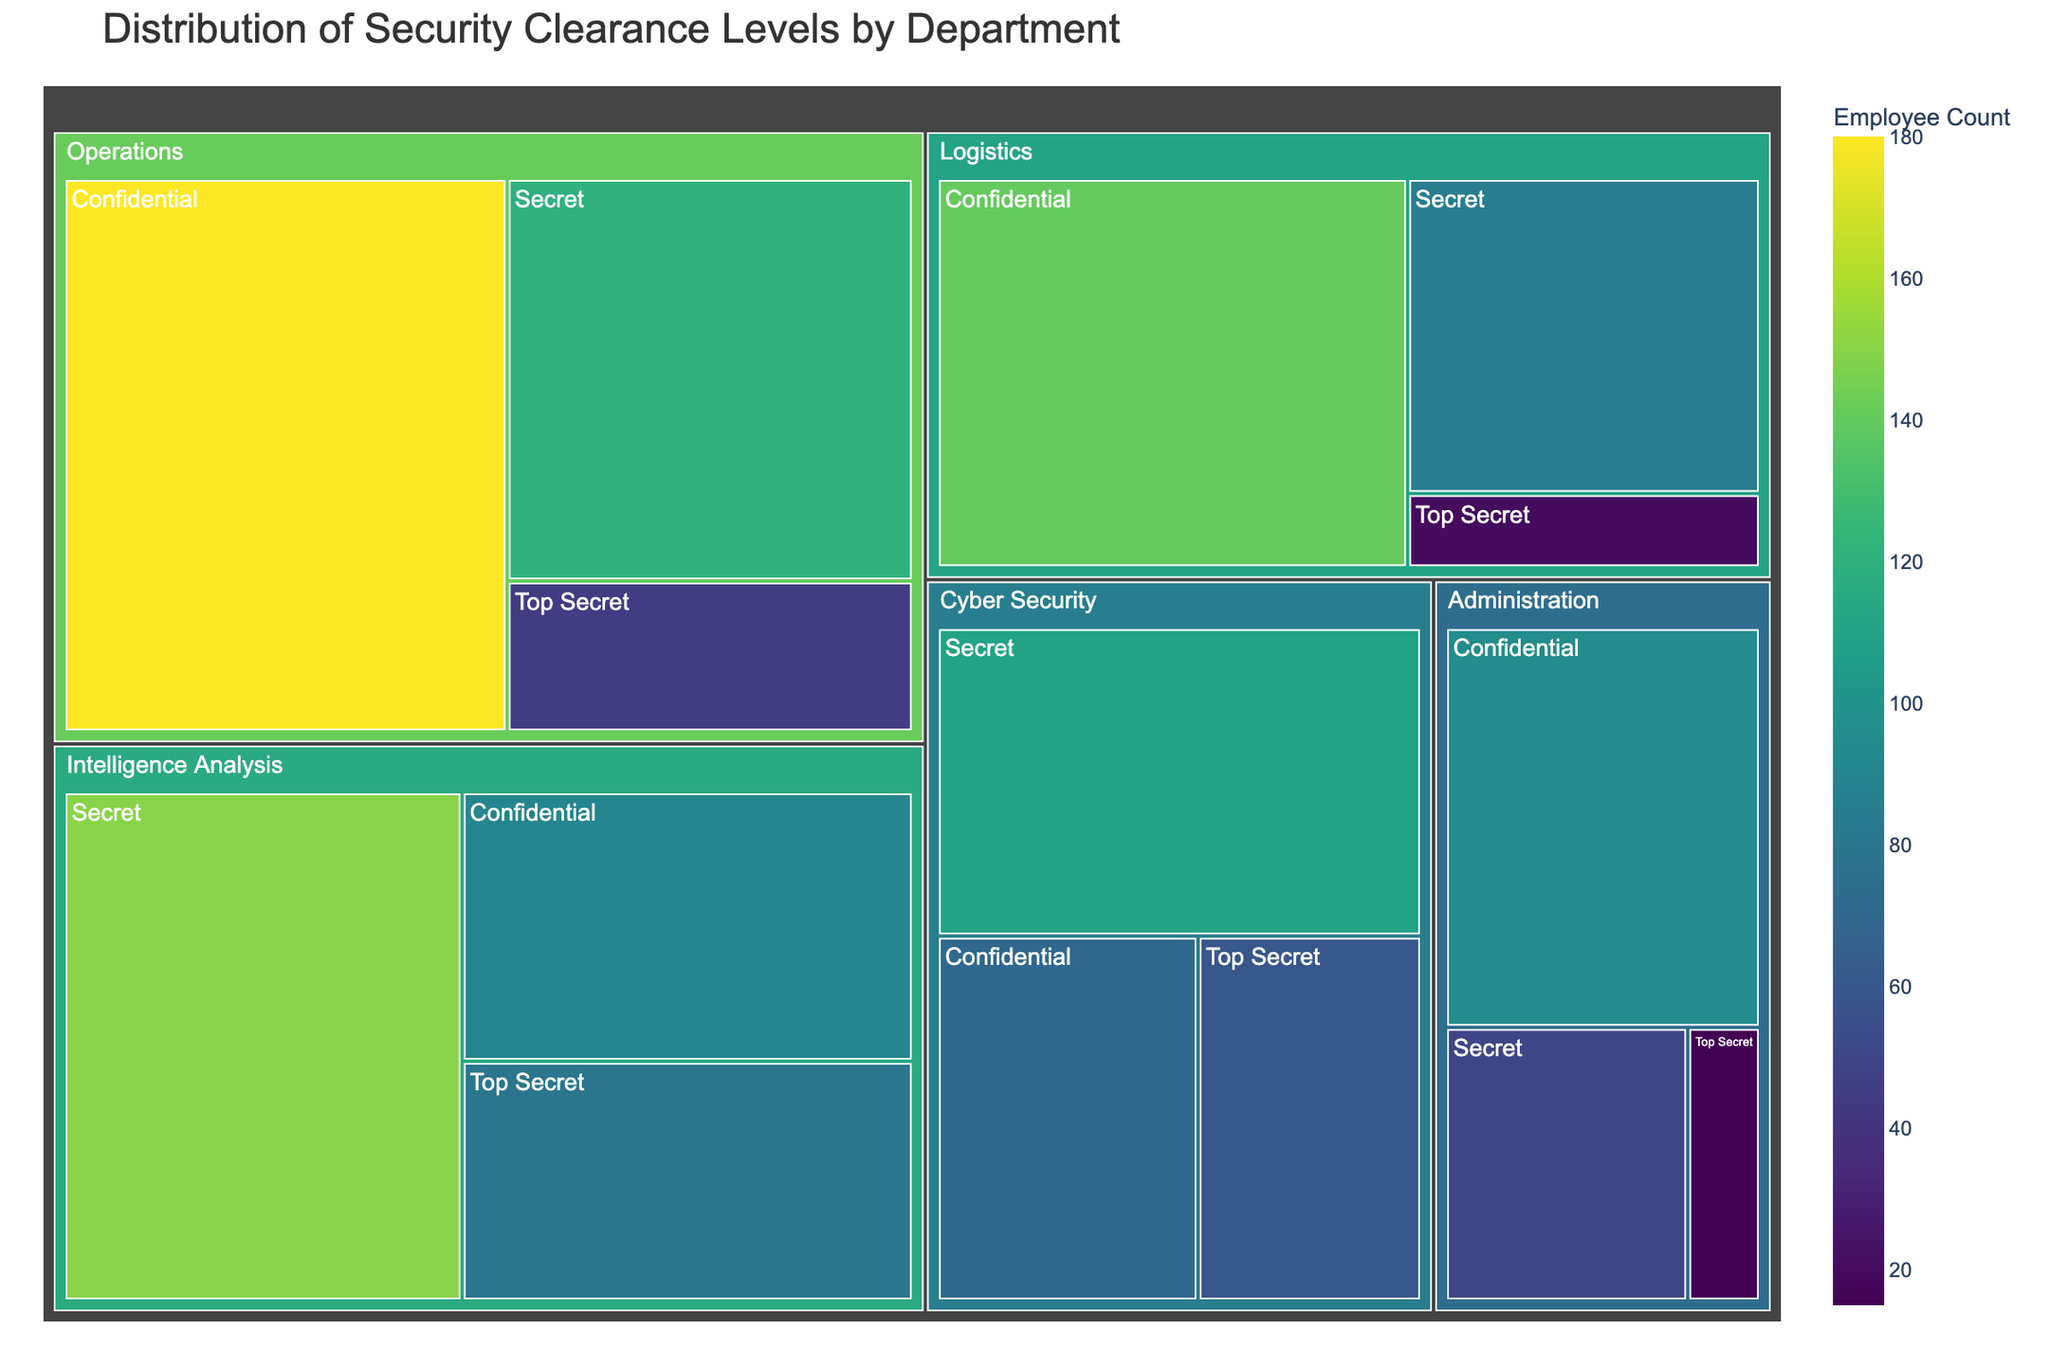What's the largest department in terms of combined employee count? The department with the largest combined employee count can be identified by summing the employee counts for each clearance level within each department. From the data, "Operations" has the largest employee count (45 + 120 + 180 = 345).
Answer: Operations Which department has the highest number of employees with Top Secret clearance? To find the department with the highest number of Top Secret clearances, we compare the counts under "Top Secret" for each department. "Intelligence Analysis” has 80, which is higher than any other department.
Answer: Intelligence Analysis How many total employees have Secret clearance across all departments? By summing the counts of employees with Secret clearance from each department: 120 (Operations) + 150 (Intelligence Analysis) + 110 (Cyber Security) + 85 (Logistics) + 50 (Administration) = 515.
Answer: 515 Which department has the least number of employees with Confidential clearance? The department with the smallest number of employees under "Confidential" clearance is found by comparing the counts. "Cyber Security" has only 70 employees with Confidential clearance, fewer than any other department.
Answer: Cyber Security What is the total number of employees in the Administration department? The total number of employees in Administration can be found by adding the counts for all clearance levels in that department: 15 (Top Secret) + 50 (Secret) + 95 (Confidential) = 160.
Answer: 160 Which department has a higher number of employees with Secret clearance, Cyber Security or Logistics? By comparing the counts of employees with Secret clearance: Cyber Security has 110, while Logistics has 85. Hence, Cyber Security has more.
Answer: Cyber Security What is the difference in the number of employees with Confidential clearance between Operations and Administration? The difference can be found by subtracting the number of employees with Confidential clearance in Administration from those in Operations: 180 (Operations) - 95 (Administration) = 85.
Answer: 85 How many employees in total have Top Secret clearance in Operations and Logistics combined? The combined total can be found by summing the Top Secret clearances in both departments: 45 (Operations) + 20 (Logistics) = 65.
Answer: 65 Which clearance level has the highest number of employees in Intelligence Analysis? By looking at the counts of employees under each clearance level in Intelligence Analysis: Top Secret (80), Secret (150), Confidential (90), the highest is Secret with 150 employees.
Answer: Secret Which two departments have an equal number of employees with Top Secret clearance? By comparing the counts of Top Secret clearances across departments, Administration (15) and Logistics (20) do not match any others, while Cyber Security (60) and also does not match any others. Hence, no two departments have the same count.
Answer: None 